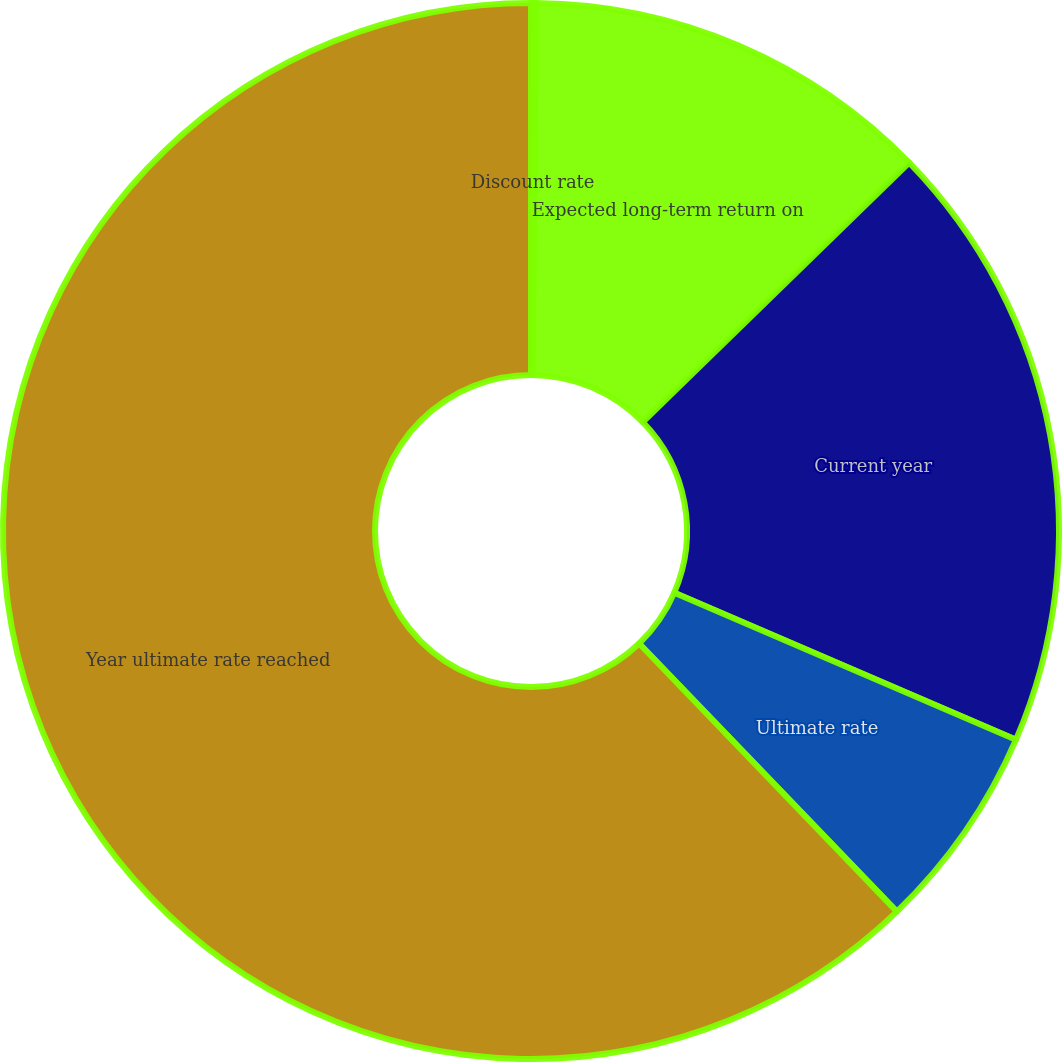Convert chart to OTSL. <chart><loc_0><loc_0><loc_500><loc_500><pie_chart><fcel>Discount rate<fcel>Expected long-term return on<fcel>Current year<fcel>Ultimate rate<fcel>Year ultimate rate reached<nl><fcel>0.15%<fcel>12.56%<fcel>18.76%<fcel>6.35%<fcel>62.19%<nl></chart> 